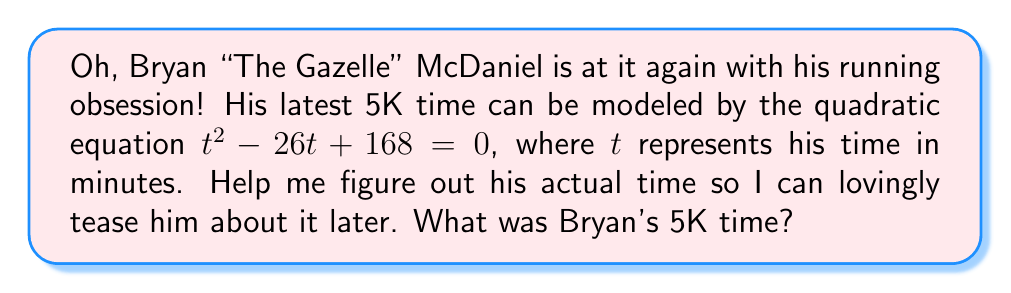Give your solution to this math problem. Alright, let's solve this step-by-step to find out Bryan's time:

1) We start with the quadratic equation:
   $$t^2 - 26t + 168 = 0$$

2) We can solve this using the quadratic formula: $t = \frac{-b \pm \sqrt{b^2 - 4ac}}{2a}$
   Where $a = 1$, $b = -26$, and $c = 168$

3) Let's substitute these values into the formula:
   $$t = \frac{26 \pm \sqrt{(-26)^2 - 4(1)(168)}}{2(1)}$$

4) Simplify under the square root:
   $$t = \frac{26 \pm \sqrt{676 - 672}}{2} = \frac{26 \pm \sqrt{4}}{2} = \frac{26 \pm 2}{2}$$

5) This gives us two solutions:
   $$t = \frac{26 + 2}{2} = 14 \text{ or } t = \frac{26 - 2}{2} = 12$$

6) Since we're dealing with a running time, the smaller positive solution makes more sense. 

Therefore, Bryan's 5K time was 12 minutes.
Answer: Bryan's 5K time was 12 minutes. 